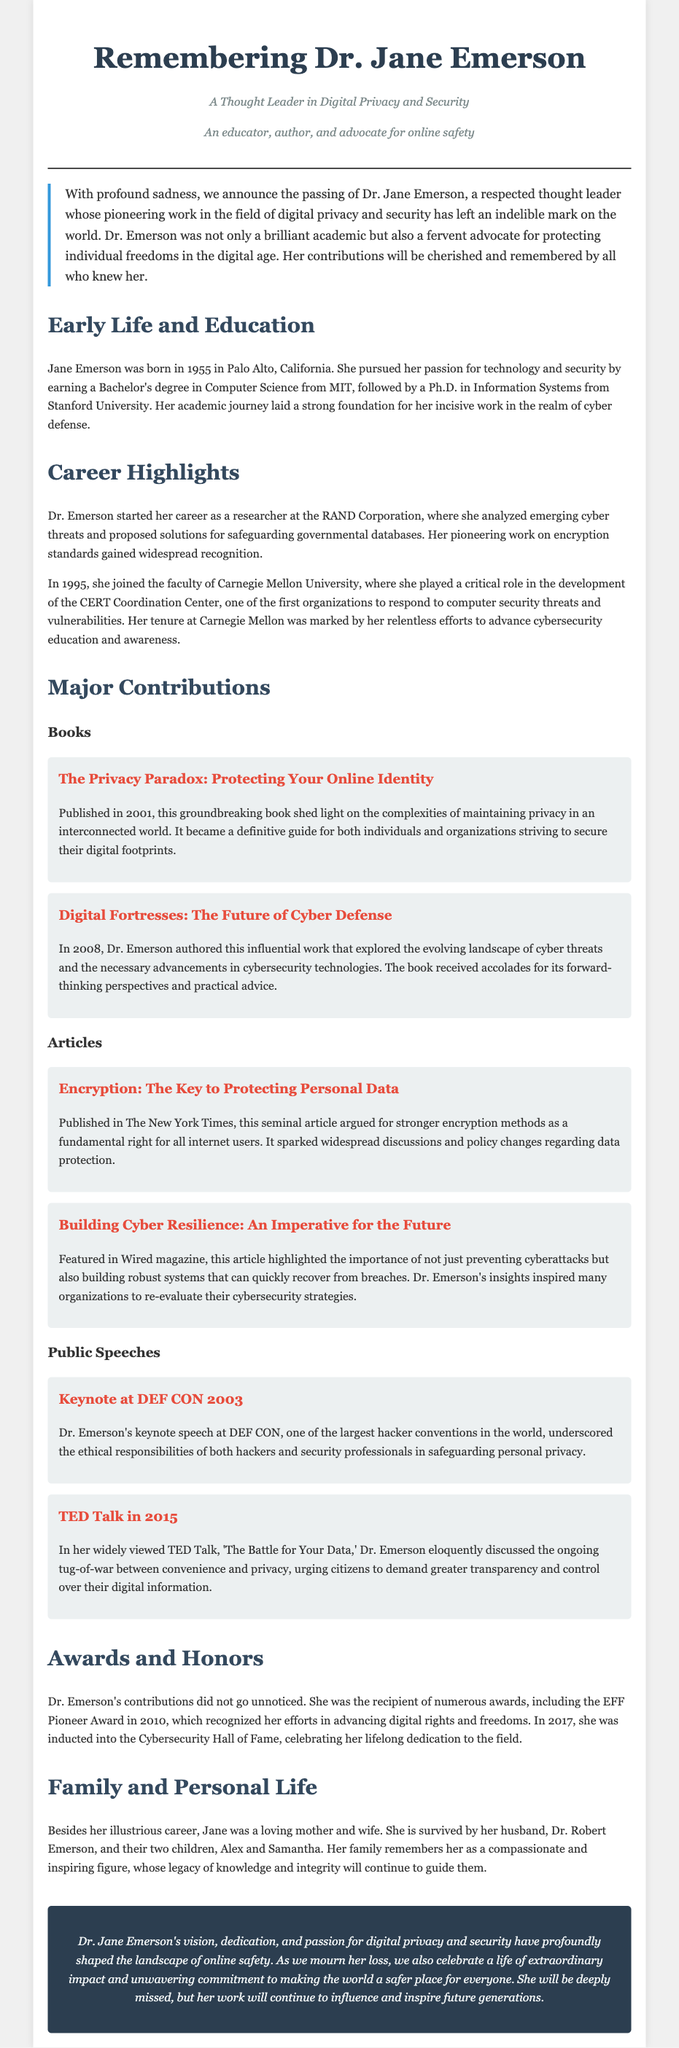What is the name of the thought leader remembered in the obituary? The obituary is about Dr. Jane Emerson, who is the central figure highlighted.
Answer: Dr. Jane Emerson In what year was "The Privacy Paradox" published? The book "The Privacy Paradox: Protecting Your Online Identity" was published in 2001.
Answer: 2001 Which award did Dr. Emerson receive in 2010? The obituary states she received the EFF Pioneer Award in 2010 for her contributions towards digital rights.
Answer: EFF Pioneer Award What notable position did Dr. Emerson hold at Carnegie Mellon University? Dr. Emerson was involved in the development of the CERT Coordination Center during her time there.
Answer: CERT Coordination Center What is the focus of Dr. Emerson's TED Talk in 2015? The TED Talk titled "The Battle for Your Data" focuses on the balance between convenience and privacy for digital citizens.
Answer: Convenience and privacy What is the main theme of Dr. Emerson's article in The New York Times? The article argues for stronger encryption methods as a fundamental right for internet users.
Answer: Stronger encryption methods How many children did Dr. Emerson have? The obituary mentions that she has two children.
Answer: Two In which state was Dr. Jane Emerson born? The document states she was born in Palo Alto, California.
Answer: California 